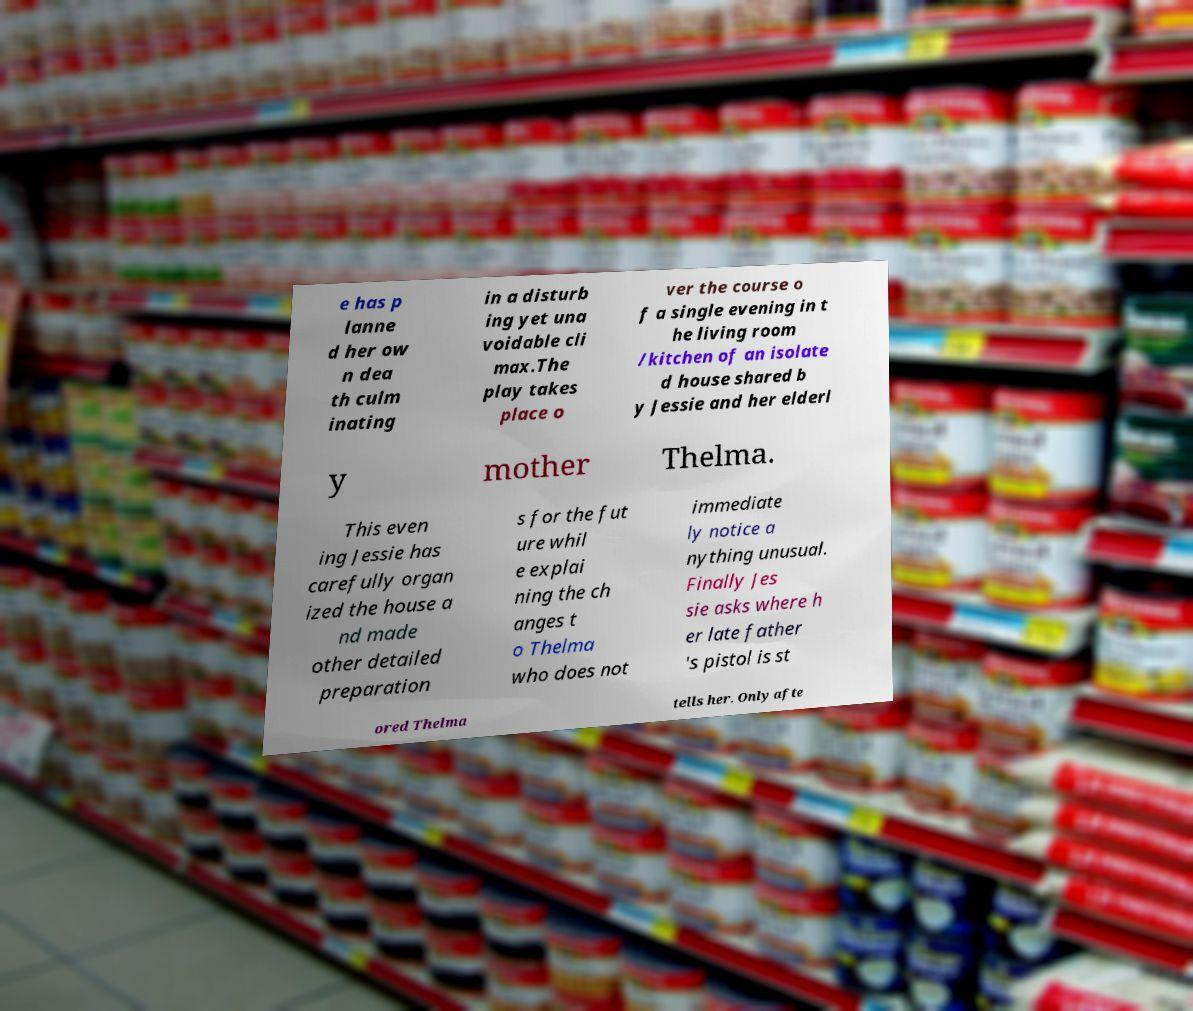Can you accurately transcribe the text from the provided image for me? e has p lanne d her ow n dea th culm inating in a disturb ing yet una voidable cli max.The play takes place o ver the course o f a single evening in t he living room /kitchen of an isolate d house shared b y Jessie and her elderl y mother Thelma. This even ing Jessie has carefully organ ized the house a nd made other detailed preparation s for the fut ure whil e explai ning the ch anges t o Thelma who does not immediate ly notice a nything unusual. Finally Jes sie asks where h er late father 's pistol is st ored Thelma tells her. Only afte 